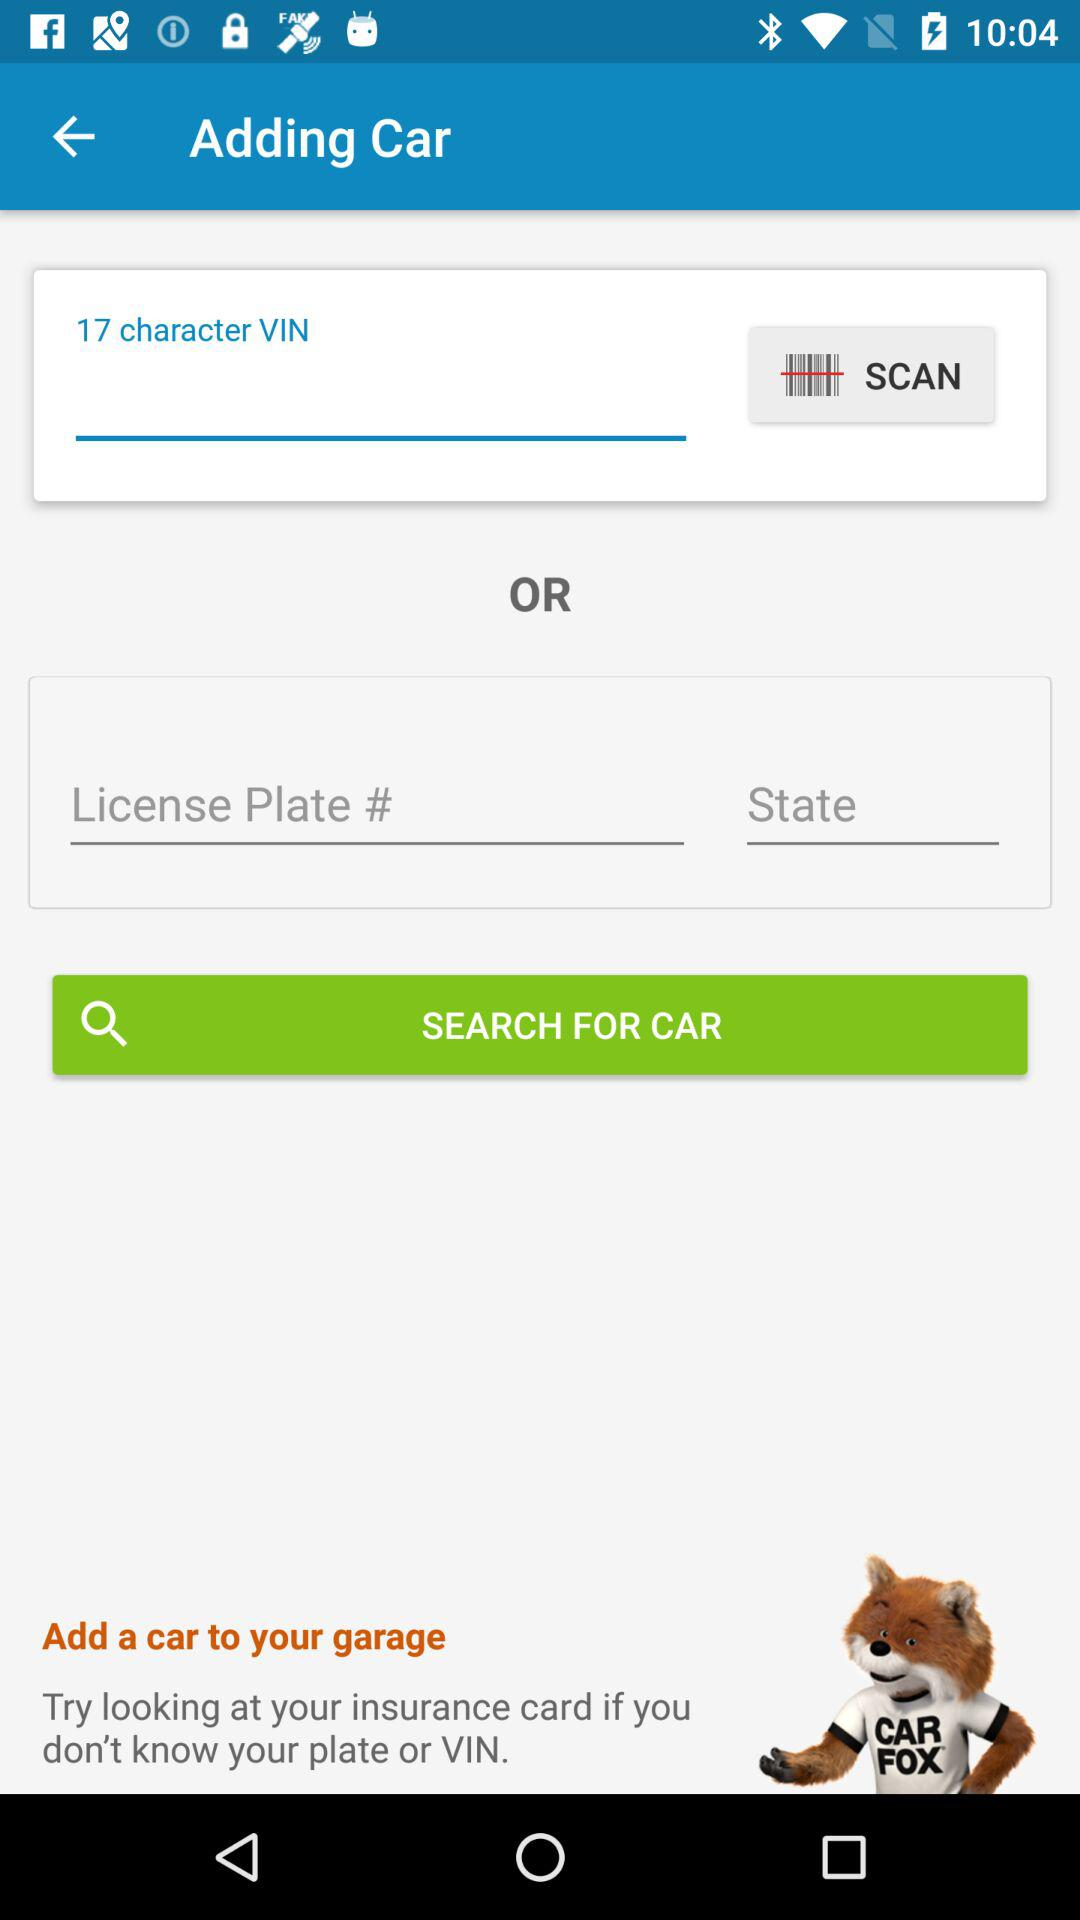What number of characters does a VIN have? A VIN has 17 characters. 